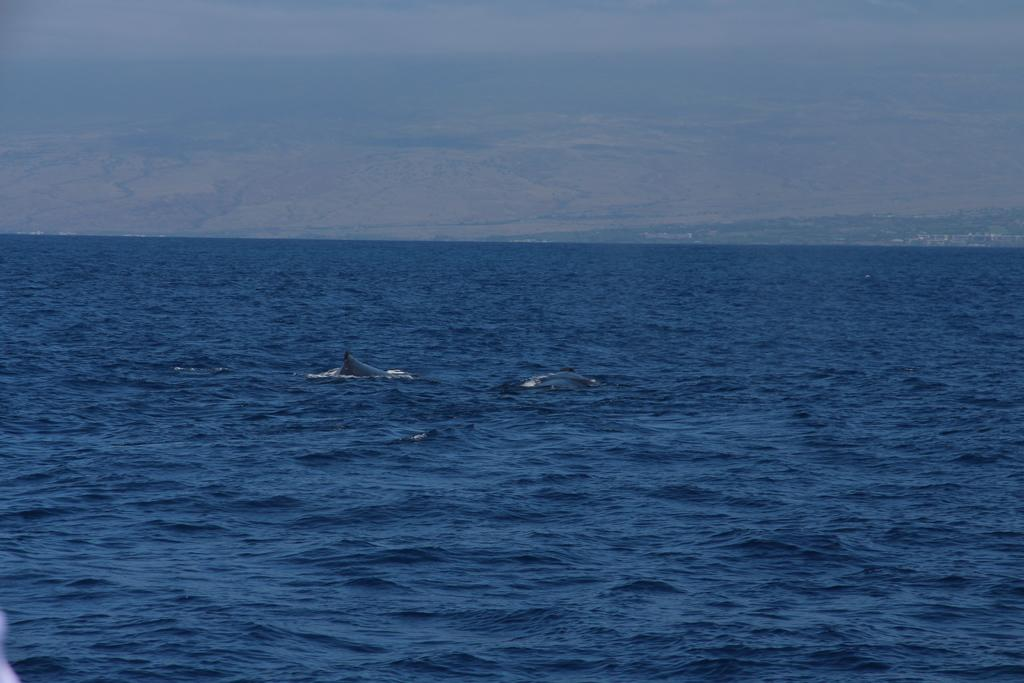What is the primary element in the image? There is water in the image. What color is the water? The water is blue in color. What type of creature can be seen in the water? There is an aquatic animal in the water. What colors are present in the background of the image? The background of the image is blue and white in color. What type of humor can be seen in the image? There is no humor present in the image; it features water, a blue and white background, and an aquatic animal. What type of education can be gained from the image? The image does not provide any educational content; it is a simple depiction of water, an aquatic animal, and a blue and white background. 